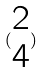Convert formula to latex. <formula><loc_0><loc_0><loc_500><loc_500>( \begin{matrix} 2 \\ 4 \end{matrix} )</formula> 